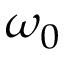<formula> <loc_0><loc_0><loc_500><loc_500>\omega _ { 0 }</formula> 